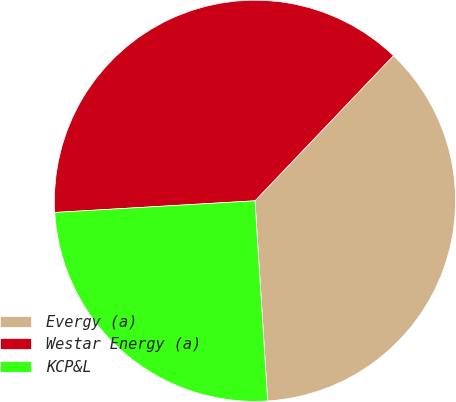<chart> <loc_0><loc_0><loc_500><loc_500><pie_chart><fcel>Evergy (a)<fcel>Westar Energy (a)<fcel>KCP&L<nl><fcel>36.87%<fcel>38.05%<fcel>25.08%<nl></chart> 